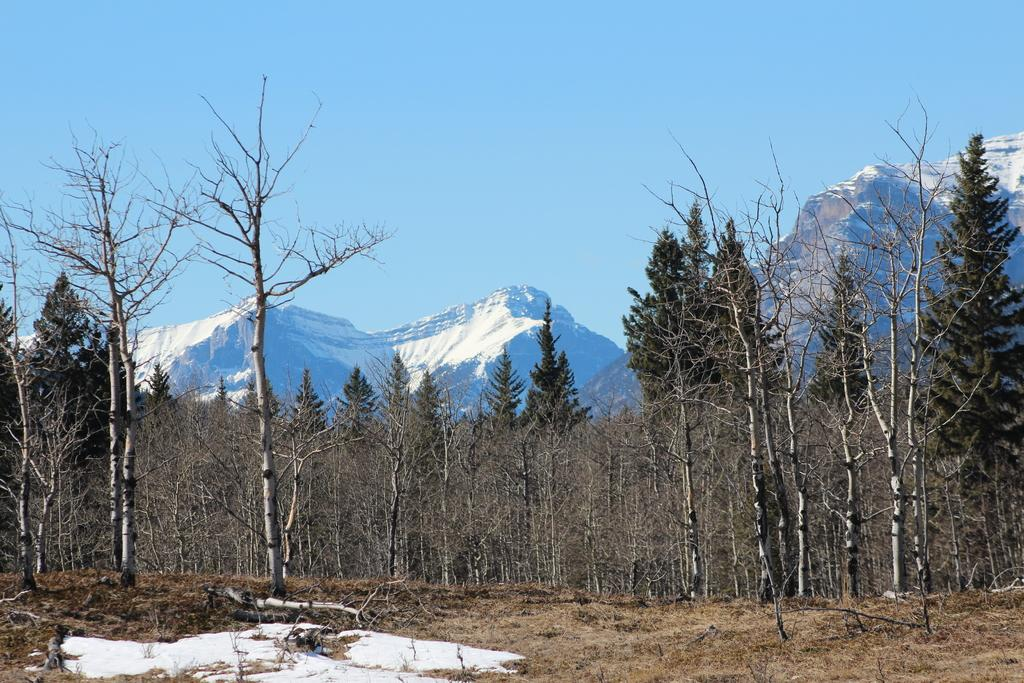What type of vegetation is present on the ground in the image? There are trees on the ground in the image. What is the weather like in the image? There is snow visible in the image, indicating a cold and likely wintery environment. What geographical features can be seen in the image? There are mountains in the image. What is visible in the background of the image? The sky is visible in the background of the image. What type of religion is practiced by the trees in the image? Trees do not practice religion, as they are inanimate objects. Can you tell me how many calculators are visible in the image? There are no calculators present in the image. 